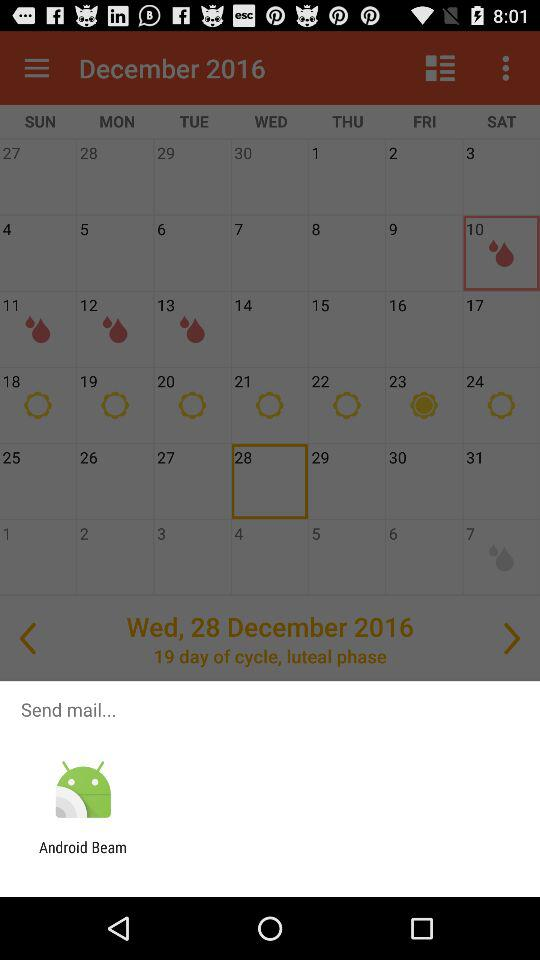What application is given for sending the mail? The given application for sending the mail is "Android Beam". 